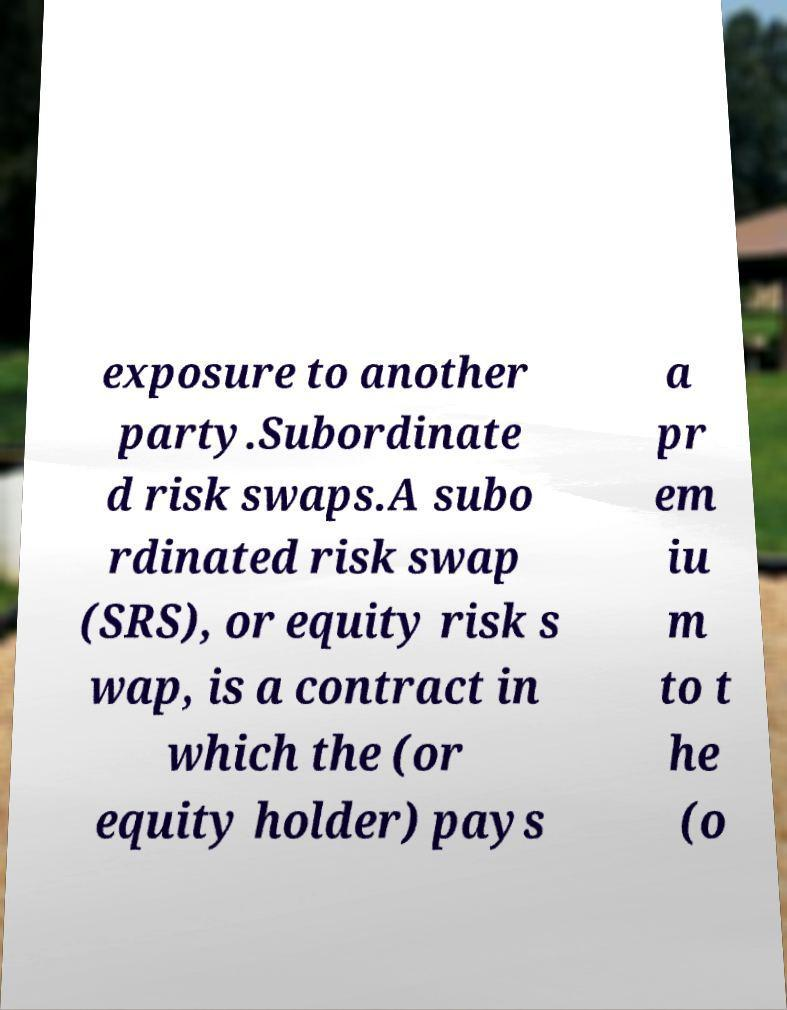Can you accurately transcribe the text from the provided image for me? exposure to another party.Subordinate d risk swaps.A subo rdinated risk swap (SRS), or equity risk s wap, is a contract in which the (or equity holder) pays a pr em iu m to t he (o 